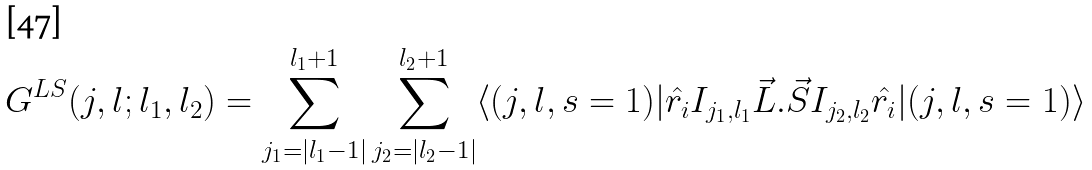<formula> <loc_0><loc_0><loc_500><loc_500>G ^ { L S } ( j , l ; l _ { 1 } , l _ { 2 } ) = \sum _ { j _ { 1 } = | l _ { 1 } - 1 | } ^ { l _ { 1 } + 1 } \sum _ { j _ { 2 } = | l _ { 2 } - 1 | } ^ { l _ { 2 } + 1 } \langle ( j , l , s = 1 ) | { \hat { r _ { i } } } I _ { j _ { 1 } , l _ { 1 } } { \vec { L } } . { \vec { S } } I _ { j _ { 2 } , l _ { 2 } } { \hat { r _ { i } } } | ( j , l , s = 1 ) \rangle</formula> 